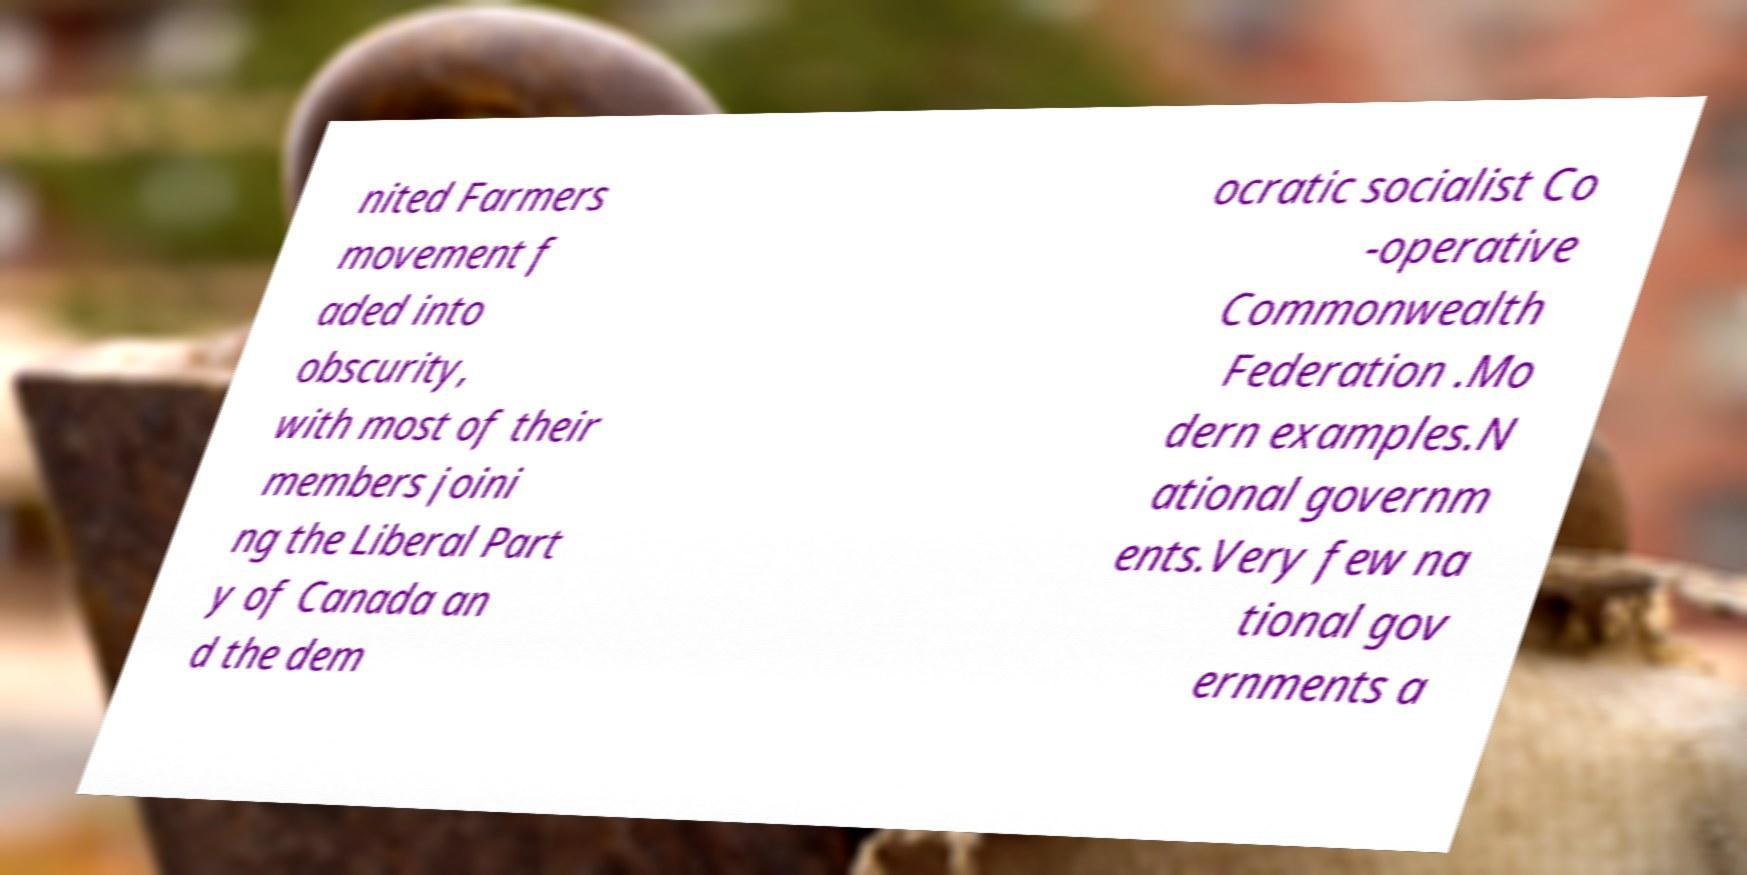Can you accurately transcribe the text from the provided image for me? nited Farmers movement f aded into obscurity, with most of their members joini ng the Liberal Part y of Canada an d the dem ocratic socialist Co -operative Commonwealth Federation .Mo dern examples.N ational governm ents.Very few na tional gov ernments a 